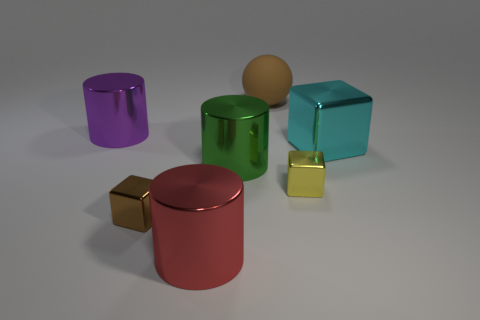Subtract all cylinders. How many objects are left? 4 Subtract 2 cylinders. How many cylinders are left? 1 Subtract all gray blocks. Subtract all blue cylinders. How many blocks are left? 3 Subtract all gray cylinders. How many cyan blocks are left? 1 Subtract all tiny gray shiny things. Subtract all brown objects. How many objects are left? 5 Add 1 red cylinders. How many red cylinders are left? 2 Add 1 big cyan things. How many big cyan things exist? 2 Add 3 green rubber things. How many objects exist? 10 Subtract all tiny metallic cubes. How many cubes are left? 1 Subtract 1 brown blocks. How many objects are left? 6 